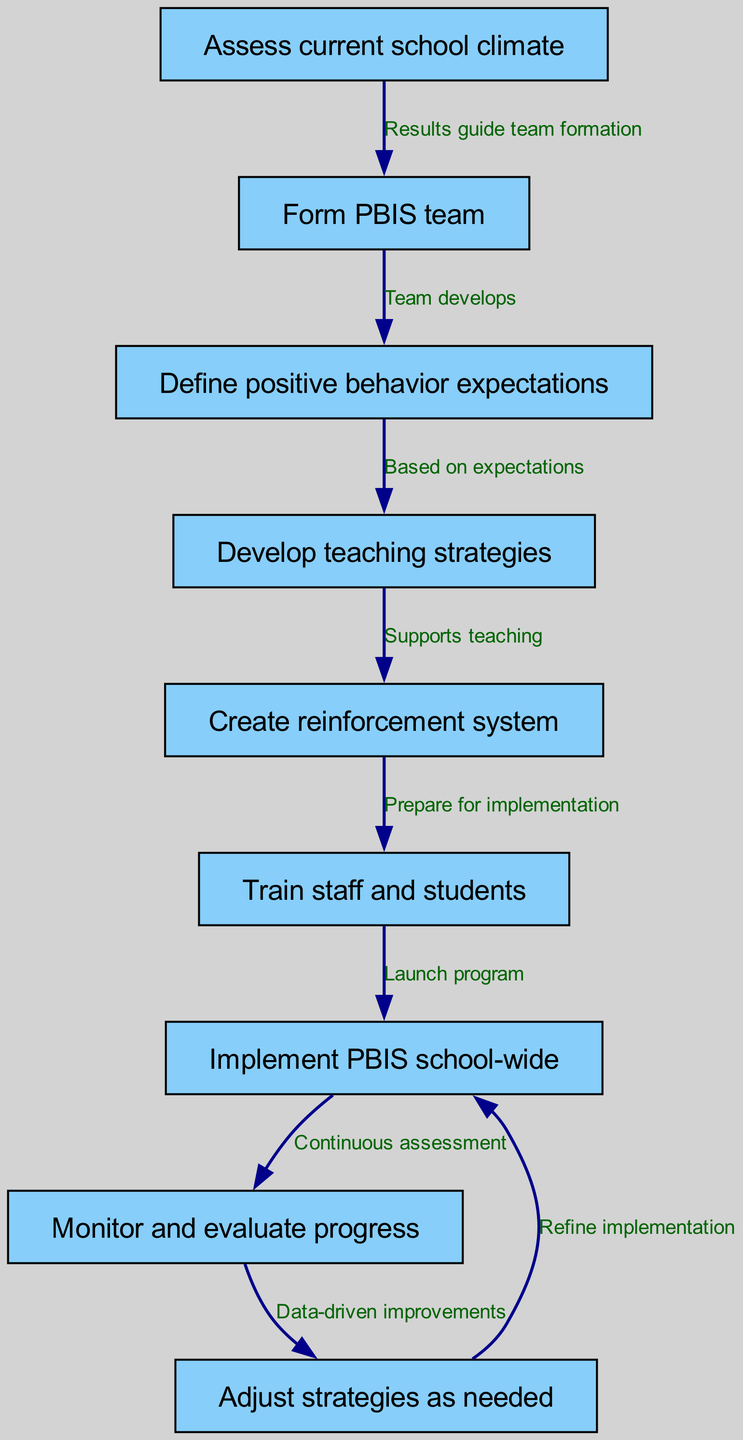What is the first step in the PBIS implementation process? The diagram shows that the first step in the process is to "Assess current school climate," which is represented as the first node.
Answer: Assess current school climate How many nodes are in the diagram? By counting the individual nodes listed in the data, there are a total of 9 nodes present in the diagram.
Answer: 9 Which node comes after forming the PBIS team? The diagram indicates that the node that follows "Form PBIS team" is "Define positive behavior expectations," as per the directed edge connecting these two nodes.
Answer: Define positive behavior expectations What connects the "Train staff and students" and "Implement PBIS school-wide" nodes? The diagram indicates that the connection between "Train staff and students" and "Implement PBIS school-wide" is represented with an edge labeled "Launch program."
Answer: Launch program What happens after monitoring and evaluating progress? According to the diagram, after "Monitor and evaluate progress," the next action is "Adjust strategies as needed," which is represented by a directed edge from the monitoring node to the adjustment node.
Answer: Adjust strategies as needed What is the relationship between assessing current school climate and forming the PBIS team? The diagram shows that the relationship is that the results from "Assess current school climate" guide the formation of the PBIS team, as indicated by the edge connecting these two nodes labeled "Results guide team formation."
Answer: Results guide team formation How many edges are in the diagram? By counting the connections between the nodes, there are a total of 8 edges that link the 9 nodes together in the flowchart.
Answer: 8 Which step is a part of continuous assessment? The node labeled "Monitor and evaluate progress" is specifically categorized under continuous assessment as it is indicated in the flowchart.
Answer: Monitor and evaluate progress What is the purpose of the "Create reinforcement system" node? The diagram states that the purpose of the "Create reinforcement system" node is to "Prepare for implementation," which supports the overall teaching strategy as outlined in the flowchart.
Answer: Prepare for implementation 